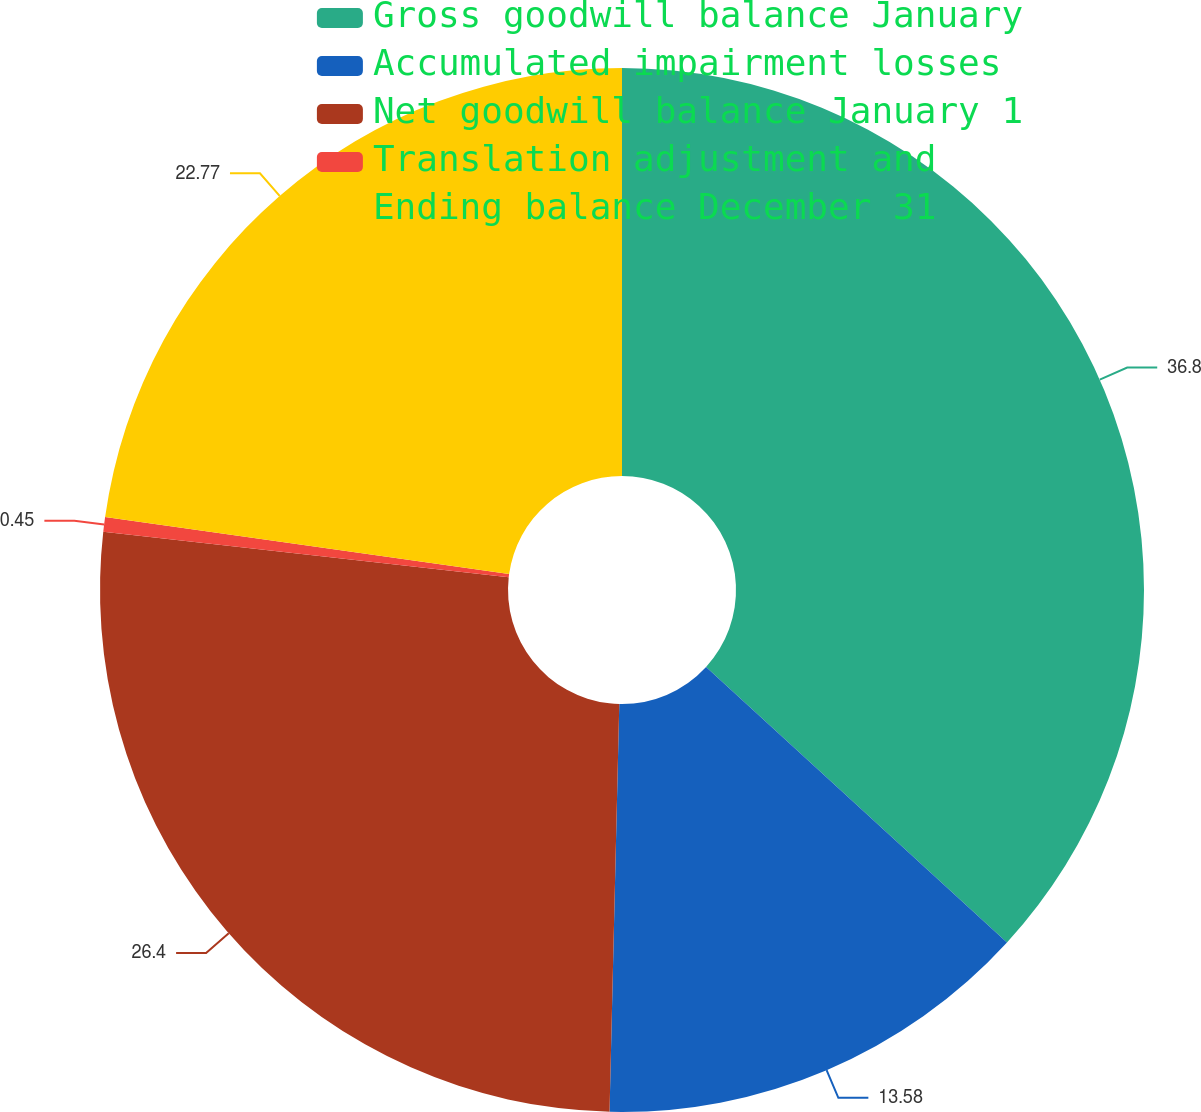Convert chart. <chart><loc_0><loc_0><loc_500><loc_500><pie_chart><fcel>Gross goodwill balance January<fcel>Accumulated impairment losses<fcel>Net goodwill balance January 1<fcel>Translation adjustment and<fcel>Ending balance December 31<nl><fcel>36.8%<fcel>13.58%<fcel>26.4%<fcel>0.45%<fcel>22.77%<nl></chart> 